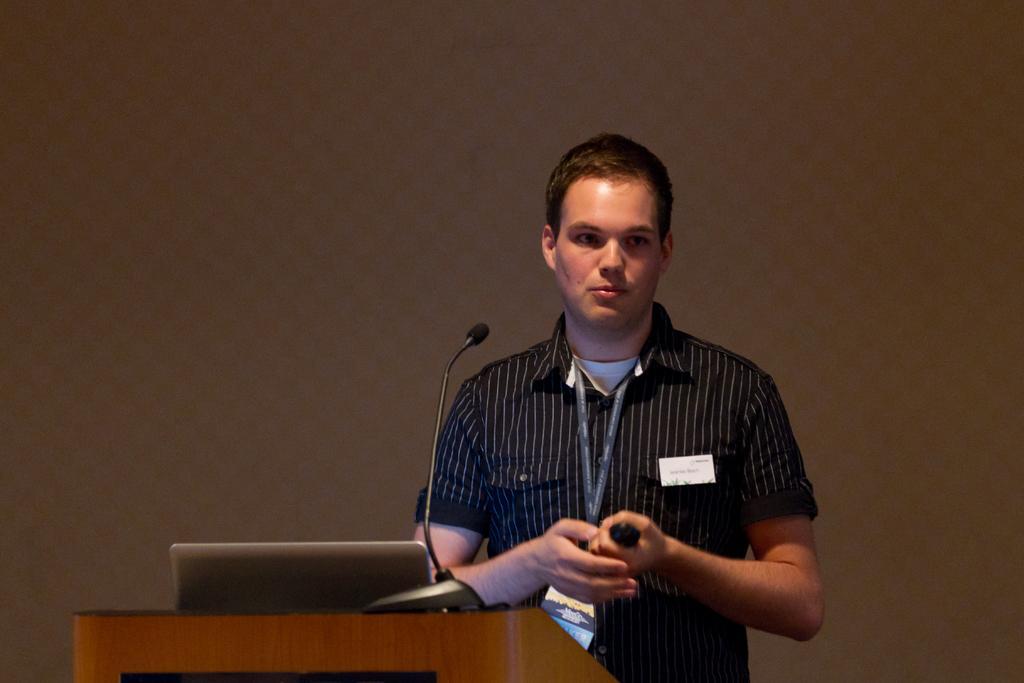Describe this image in one or two sentences. In the center of the image we can see one person is standing and he is holding some object. In front of him, there is a wooden stand. On the stand, we can see a microphone and some object. In the background, we can see it is blurred. 